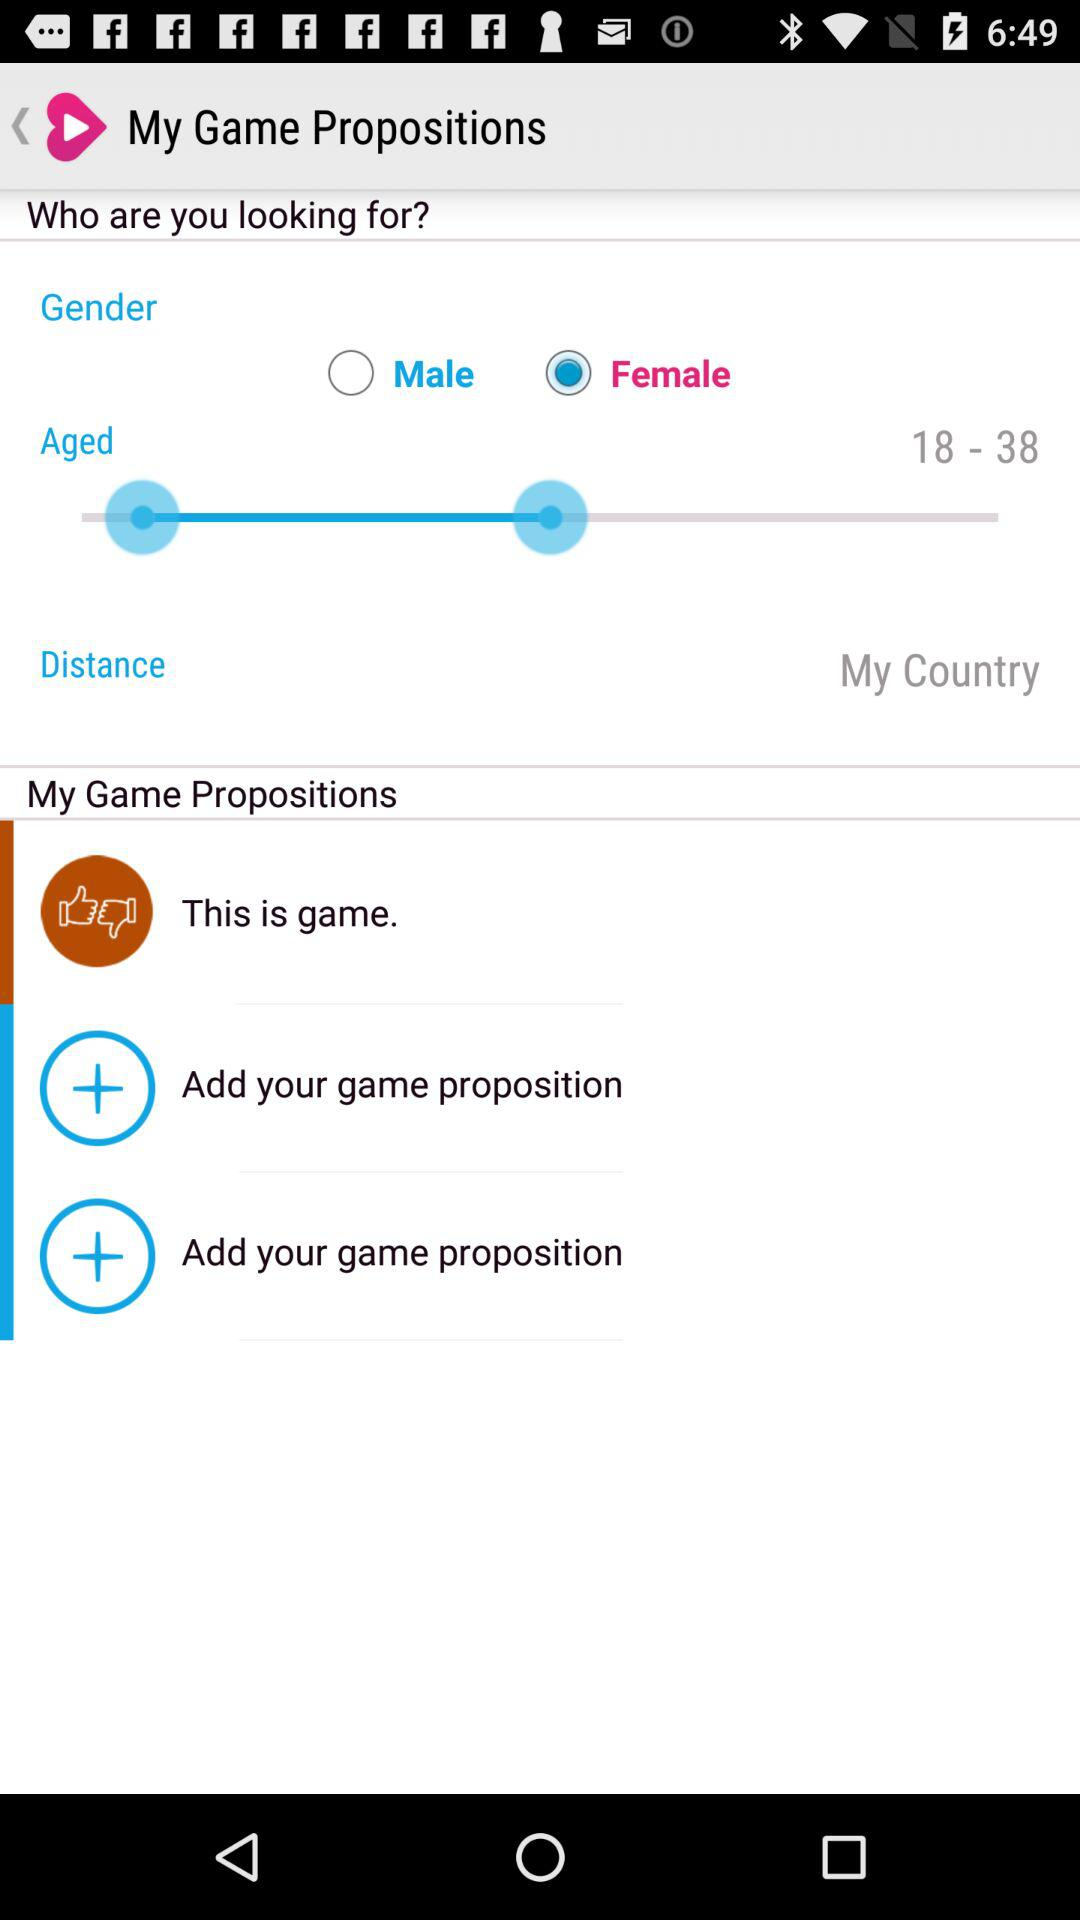What is the age group of the user? The age group of the user is between 18-38. 